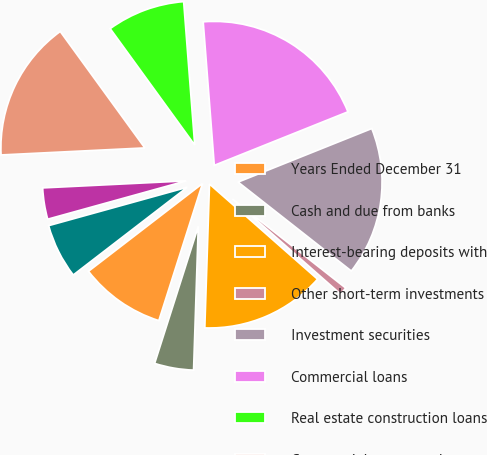Convert chart to OTSL. <chart><loc_0><loc_0><loc_500><loc_500><pie_chart><fcel>Years Ended December 31<fcel>Cash and due from banks<fcel>Interest-bearing deposits with<fcel>Other short-term investments<fcel>Investment securities<fcel>Commercial loans<fcel>Real estate construction loans<fcel>Commercial mortgage loans<fcel>Lease financing<fcel>International loans<nl><fcel>9.65%<fcel>4.39%<fcel>14.03%<fcel>0.89%<fcel>16.66%<fcel>20.16%<fcel>8.77%<fcel>15.78%<fcel>3.52%<fcel>6.14%<nl></chart> 